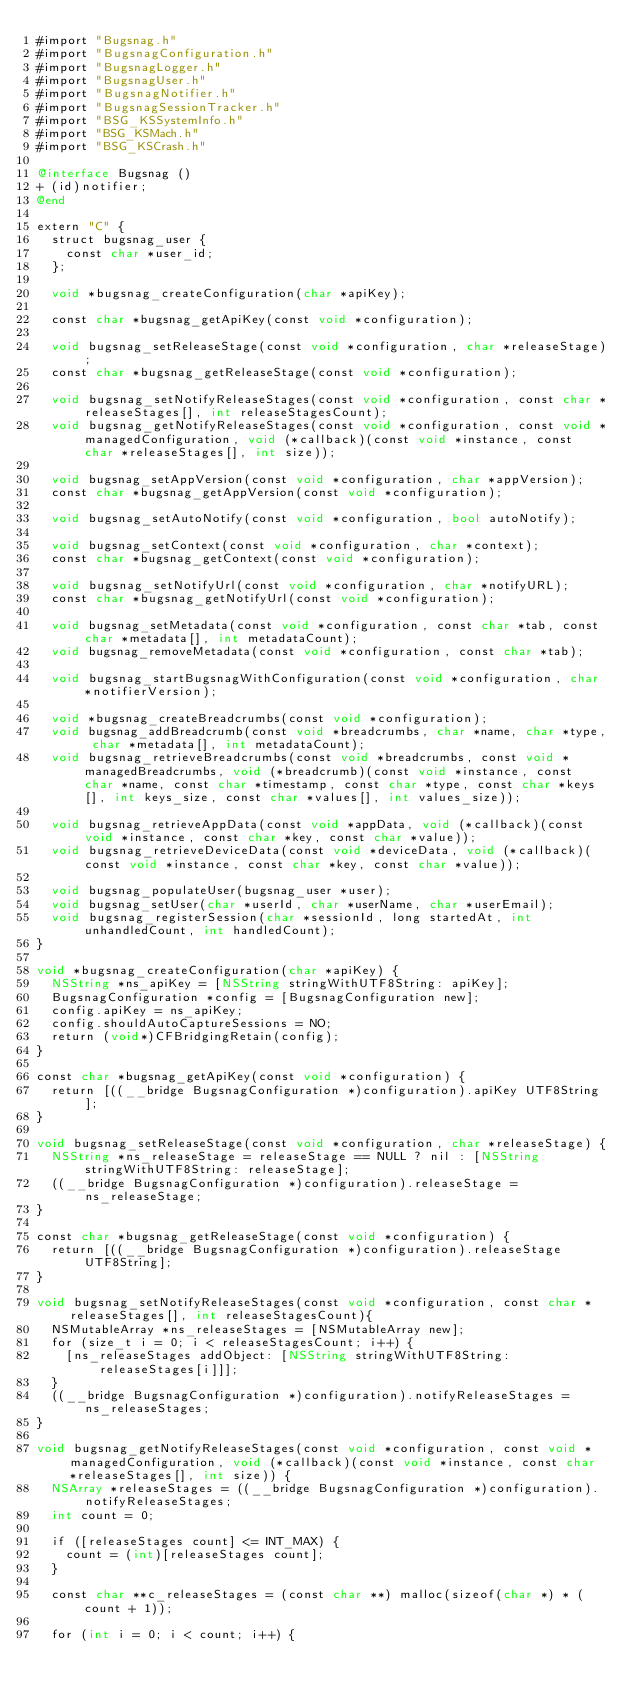Convert code to text. <code><loc_0><loc_0><loc_500><loc_500><_ObjectiveC_>#import "Bugsnag.h"
#import "BugsnagConfiguration.h"
#import "BugsnagLogger.h"
#import "BugsnagUser.h"
#import "BugsnagNotifier.h"
#import "BugsnagSessionTracker.h"
#import "BSG_KSSystemInfo.h"
#import "BSG_KSMach.h"
#import "BSG_KSCrash.h"

@interface Bugsnag ()
+ (id)notifier;
@end

extern "C" {
  struct bugsnag_user {
    const char *user_id;
  };

  void *bugsnag_createConfiguration(char *apiKey);

  const char *bugsnag_getApiKey(const void *configuration);

  void bugsnag_setReleaseStage(const void *configuration, char *releaseStage);
  const char *bugsnag_getReleaseStage(const void *configuration);

  void bugsnag_setNotifyReleaseStages(const void *configuration, const char *releaseStages[], int releaseStagesCount);
  void bugsnag_getNotifyReleaseStages(const void *configuration, const void *managedConfiguration, void (*callback)(const void *instance, const char *releaseStages[], int size));

  void bugsnag_setAppVersion(const void *configuration, char *appVersion);
  const char *bugsnag_getAppVersion(const void *configuration);

  void bugsnag_setAutoNotify(const void *configuration, bool autoNotify);

  void bugsnag_setContext(const void *configuration, char *context);
  const char *bugsnag_getContext(const void *configuration);

  void bugsnag_setNotifyUrl(const void *configuration, char *notifyURL);
  const char *bugsnag_getNotifyUrl(const void *configuration);

  void bugsnag_setMetadata(const void *configuration, const char *tab, const char *metadata[], int metadataCount);
  void bugsnag_removeMetadata(const void *configuration, const char *tab);

  void bugsnag_startBugsnagWithConfiguration(const void *configuration, char *notifierVersion);

  void *bugsnag_createBreadcrumbs(const void *configuration);
  void bugsnag_addBreadcrumb(const void *breadcrumbs, char *name, char *type, char *metadata[], int metadataCount);
  void bugsnag_retrieveBreadcrumbs(const void *breadcrumbs, const void *managedBreadcrumbs, void (*breadcrumb)(const void *instance, const char *name, const char *timestamp, const char *type, const char *keys[], int keys_size, const char *values[], int values_size));

  void bugsnag_retrieveAppData(const void *appData, void (*callback)(const void *instance, const char *key, const char *value));
  void bugsnag_retrieveDeviceData(const void *deviceData, void (*callback)(const void *instance, const char *key, const char *value));

  void bugsnag_populateUser(bugsnag_user *user);
  void bugsnag_setUser(char *userId, char *userName, char *userEmail);
  void bugsnag_registerSession(char *sessionId, long startedAt, int unhandledCount, int handledCount);
}

void *bugsnag_createConfiguration(char *apiKey) {
  NSString *ns_apiKey = [NSString stringWithUTF8String: apiKey];
  BugsnagConfiguration *config = [BugsnagConfiguration new];
  config.apiKey = ns_apiKey;
  config.shouldAutoCaptureSessions = NO;
  return (void*)CFBridgingRetain(config);
}

const char *bugsnag_getApiKey(const void *configuration) {
  return [((__bridge BugsnagConfiguration *)configuration).apiKey UTF8String];
}

void bugsnag_setReleaseStage(const void *configuration, char *releaseStage) {
  NSString *ns_releaseStage = releaseStage == NULL ? nil : [NSString stringWithUTF8String: releaseStage];
  ((__bridge BugsnagConfiguration *)configuration).releaseStage = ns_releaseStage;
}

const char *bugsnag_getReleaseStage(const void *configuration) {
  return [((__bridge BugsnagConfiguration *)configuration).releaseStage UTF8String];
}

void bugsnag_setNotifyReleaseStages(const void *configuration, const char *releaseStages[], int releaseStagesCount){
  NSMutableArray *ns_releaseStages = [NSMutableArray new];
  for (size_t i = 0; i < releaseStagesCount; i++) {
    [ns_releaseStages addObject: [NSString stringWithUTF8String: releaseStages[i]]];
  }
  ((__bridge BugsnagConfiguration *)configuration).notifyReleaseStages = ns_releaseStages;
}

void bugsnag_getNotifyReleaseStages(const void *configuration, const void *managedConfiguration, void (*callback)(const void *instance, const char *releaseStages[], int size)) {
  NSArray *releaseStages = ((__bridge BugsnagConfiguration *)configuration).notifyReleaseStages;
  int count = 0;

  if ([releaseStages count] <= INT_MAX) {
    count = (int)[releaseStages count];
  }

  const char **c_releaseStages = (const char **) malloc(sizeof(char *) * (count + 1));

  for (int i = 0; i < count; i++) {</code> 